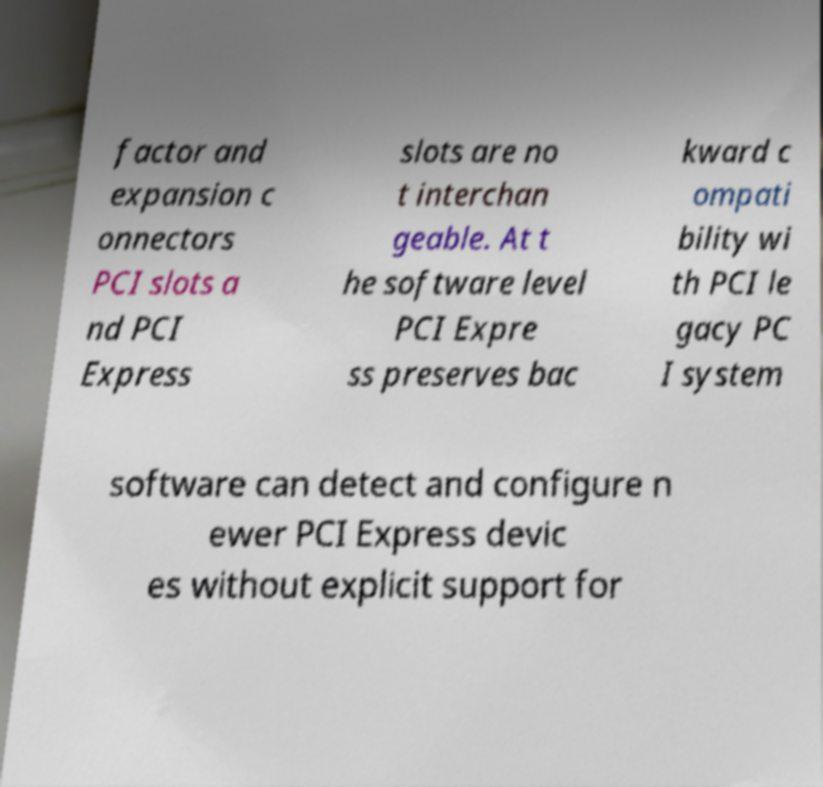Could you extract and type out the text from this image? factor and expansion c onnectors PCI slots a nd PCI Express slots are no t interchan geable. At t he software level PCI Expre ss preserves bac kward c ompati bility wi th PCI le gacy PC I system software can detect and configure n ewer PCI Express devic es without explicit support for 